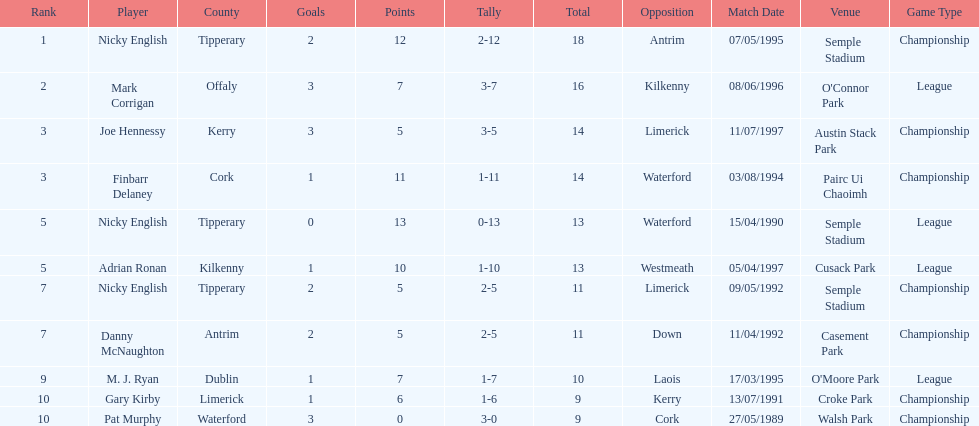What was the average sum of nicky english and mark corrigan's totals? 17. 